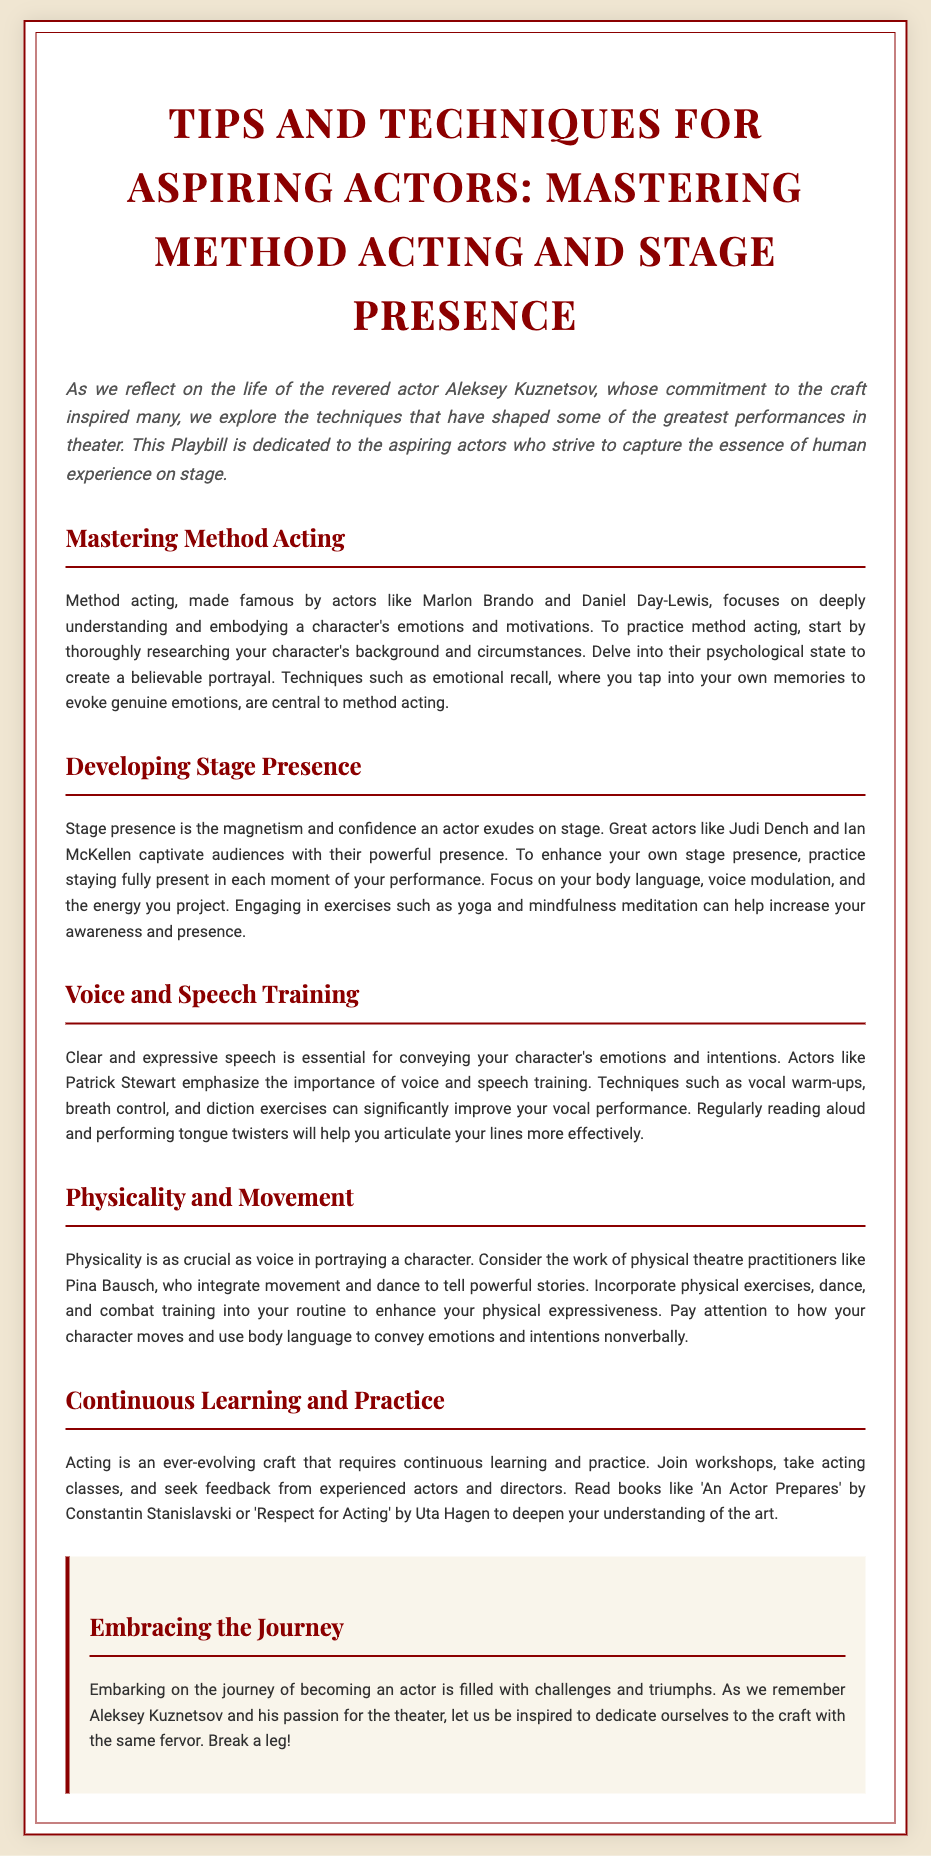What is the title of the Playbill? The title of the Playbill is presented prominently at the top of the document.
Answer: Tips and Techniques for Aspiring Actors: Mastering Method Acting and Stage Presence Who is the Playbill dedicated to? The dedication section of the Playbill mentions the target audience for the tips.
Answer: Aspiring actors Which technique is stressed for creating a believable portrayal in method acting? The Playbill highlights a specific technique used in method acting.
Answer: Emotional recall Name one actor mentioned as an example of great stage presence. Specific actors are mentioned to exemplify stage presence in the document.
Answer: Judi Dench What type of training is emphasized for clear and expressive speech? The section discusses the importance of this training for actors.
Answer: Voice and speech training What is a recommended exercise to improve physical expressiveness? Within the physicality and movement section, various activities are suggested.
Answer: Dance Which book is recommended for deepening understanding of acting? The Playbill suggests literature to enhance knowledge of the craft.
Answer: An Actor Prepares What should actors engage in to increase awareness and presence? The document proposes practices to improve an actor’s stage presence.
Answer: Yoga and mindfulness meditation What is the concluding message regarding the acting journey? The conclusion provides encouragement on the path of becoming an actor.
Answer: Embracing the journey 